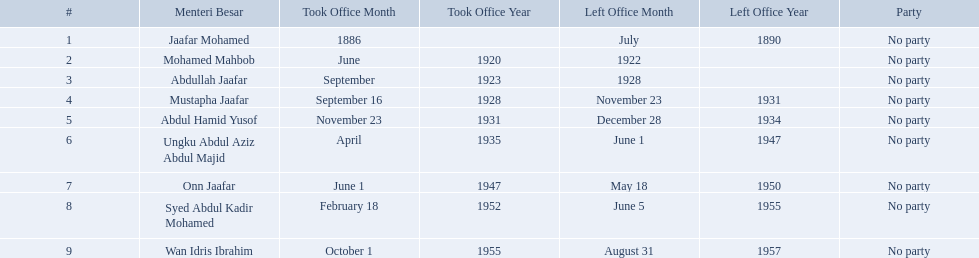Who were the menteri besar of johor? Jaafar Mohamed, Mohamed Mahbob, Abdullah Jaafar, Mustapha Jaafar, Abdul Hamid Yusof, Ungku Abdul Aziz Abdul Majid, Onn Jaafar, Syed Abdul Kadir Mohamed, Wan Idris Ibrahim. Who served the longest? Ungku Abdul Aziz Abdul Majid. Who were all of the menteri besars? Jaafar Mohamed, Mohamed Mahbob, Abdullah Jaafar, Mustapha Jaafar, Abdul Hamid Yusof, Ungku Abdul Aziz Abdul Majid, Onn Jaafar, Syed Abdul Kadir Mohamed, Wan Idris Ibrahim. When did they take office? 1886, June 1920, September 1923, September 16, 1928, November 23, 1931, April 1935, June 1, 1947, February 18, 1952, October 1, 1955. And when did they leave? July 1890, 1922, 1928, November 23, 1931, December 28, 1934, June 1, 1947, May 18, 1950, June 5, 1955, August 31, 1957. Now, who was in office for less than four years? Mohamed Mahbob. 